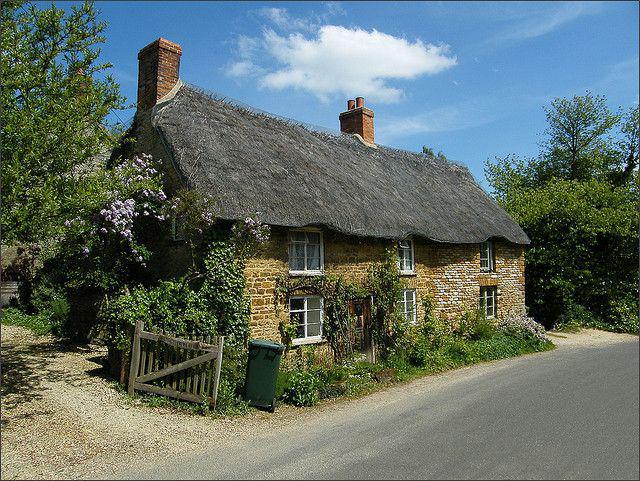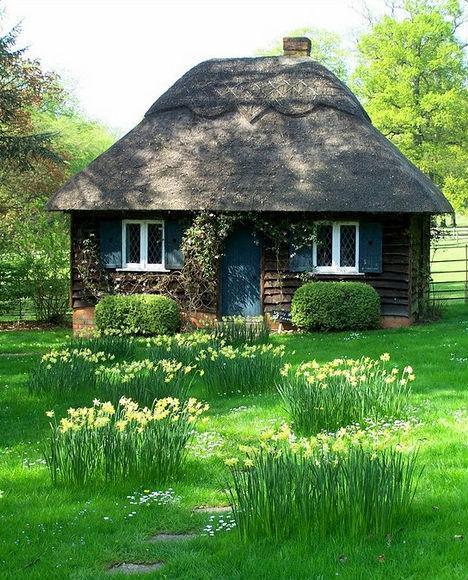The first image is the image on the left, the second image is the image on the right. Considering the images on both sides, is "In at least one image there is a white house with black strip trim." valid? Answer yes or no. No. The first image is the image on the left, the second image is the image on the right. Considering the images on both sides, is "Each house shows only one chimney" valid? Answer yes or no. No. 